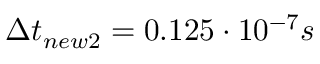<formula> <loc_0><loc_0><loc_500><loc_500>\Delta t _ { n e w 2 } = 0 . 1 2 5 \cdot 1 0 ^ { - 7 } s</formula> 